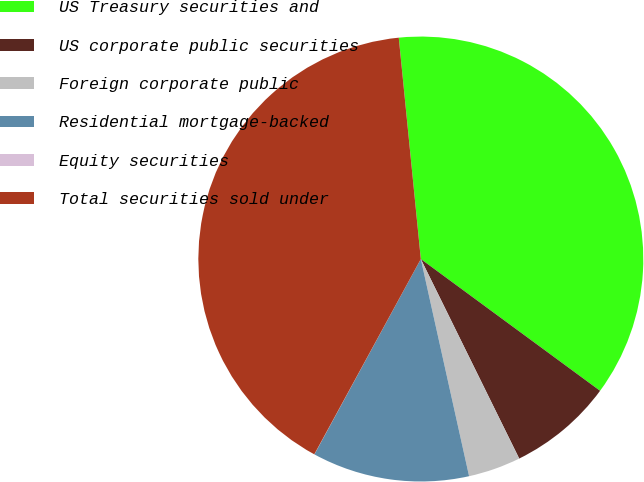<chart> <loc_0><loc_0><loc_500><loc_500><pie_chart><fcel>US Treasury securities and<fcel>US corporate public securities<fcel>Foreign corporate public<fcel>Residential mortgage-backed<fcel>Equity securities<fcel>Total securities sold under<nl><fcel>36.67%<fcel>7.62%<fcel>3.81%<fcel>11.42%<fcel>0.01%<fcel>40.47%<nl></chart> 